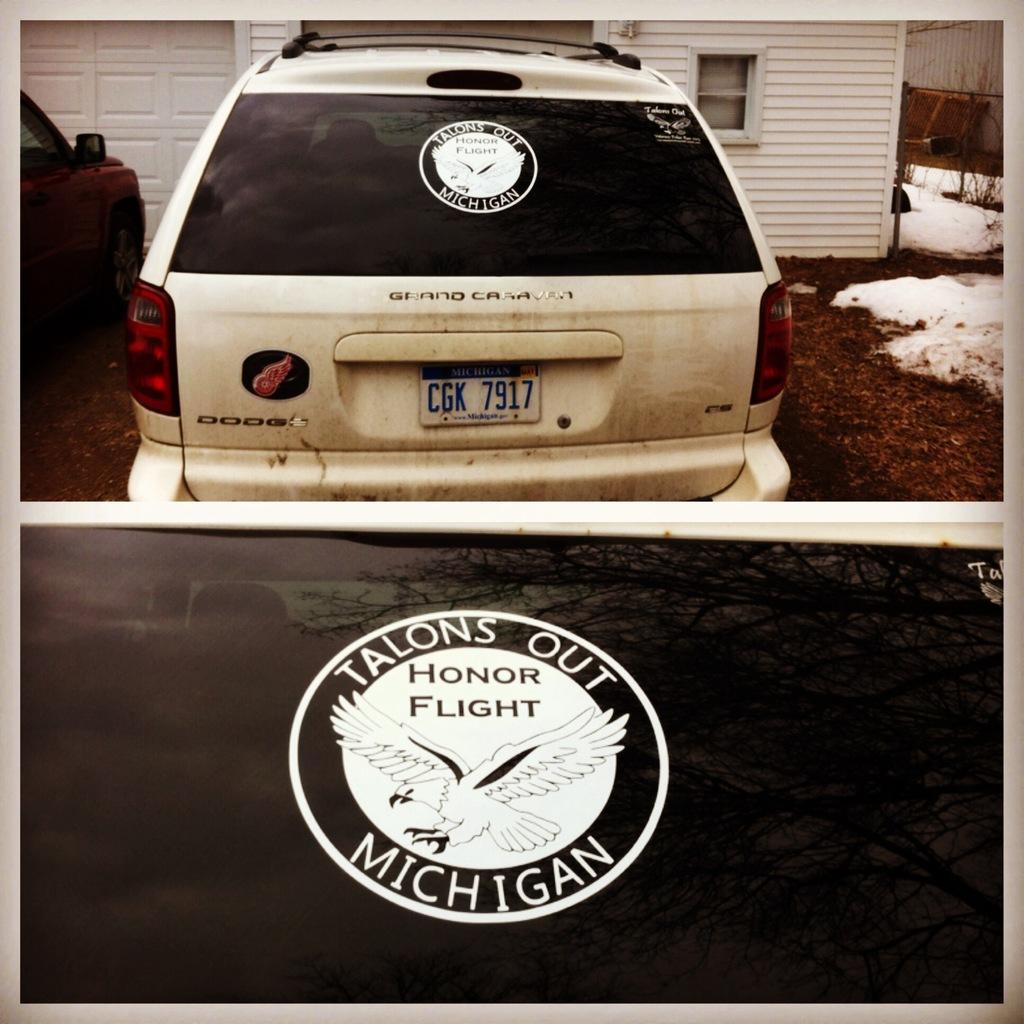Can you describe this image briefly? In this picture we can see some text at the bottom, there are two cars in the front, in the background there is a house, on the right side we can see snow and grass. 